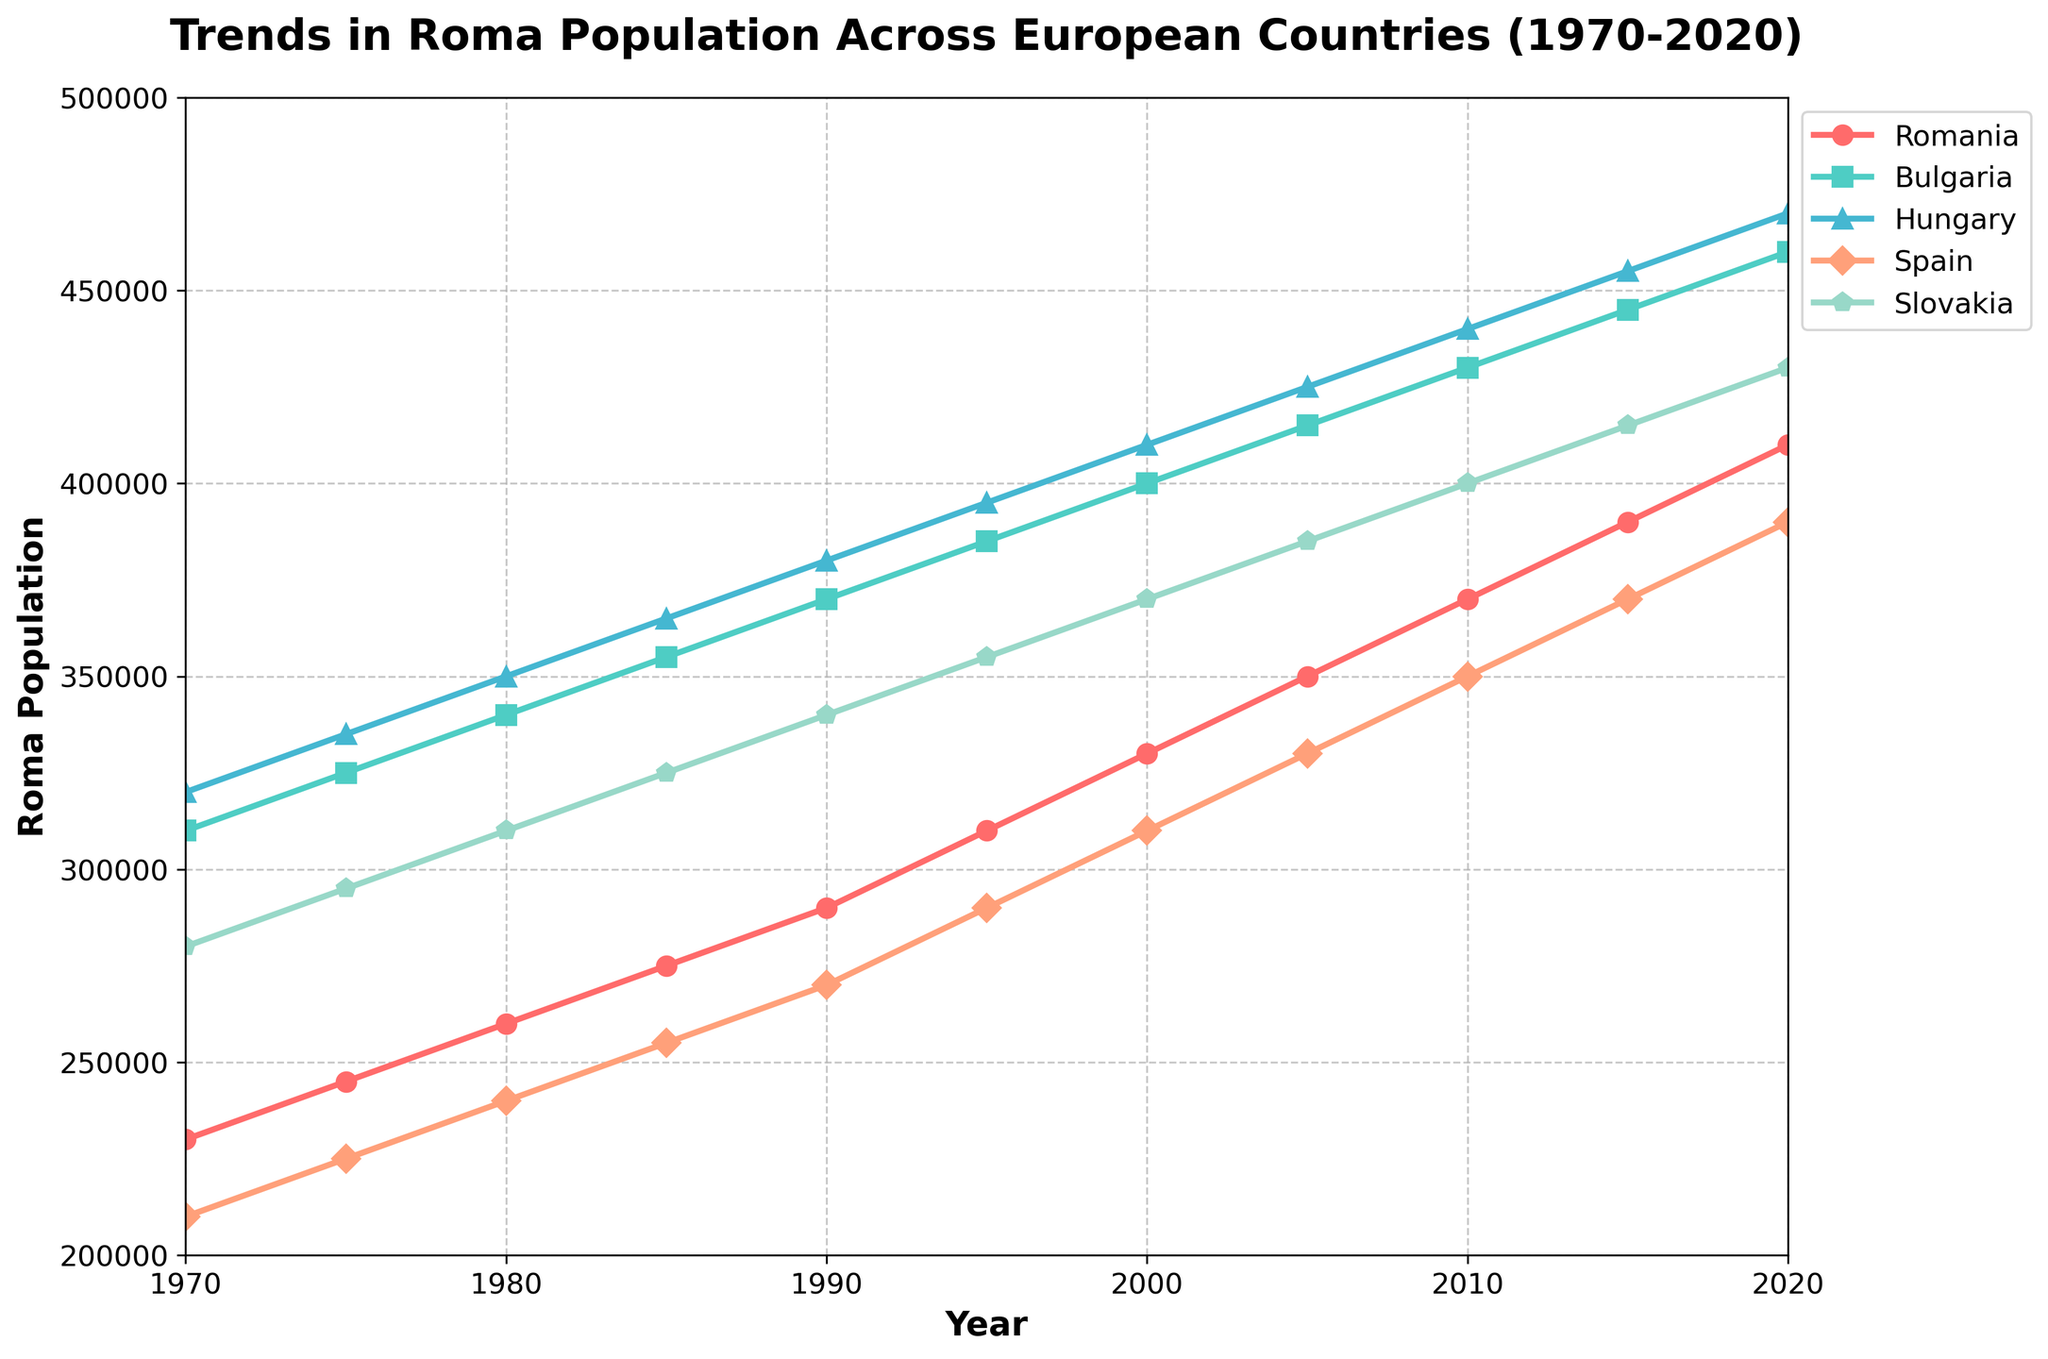What is the trend in the Roma population for Romania from 1970 to 2020? The line representing Romania's Roma population starts from 230,000 in 1970 and steadily increases to 410,000 in 2020, indicating a continuous upward trend.
Answer: Continuous upward trend Which country had the highest Roma population in 2020? By comparing the endpoints of all lines in 2020, Bulgaria's line reaches 460,000, which is higher than the lines of Romania, Hungary, Spain, and Slovakia.
Answer: Bulgaria What is the difference in Roma population between Hungary and Spain in 2010? In 2010, Hungary's Roma population is 440,000, and Spain's is 350,000. The difference is calculated by subtracting 350,000 from 440,000.
Answer: 90,000 Which country experienced the greatest increase in Roma population between 1970 and 2020? By examining the lengths of the lines' increase, Bulgaria increased from 310,000 to 460,000, an increase of 150,000; no other country shows a larger increase.
Answer: Bulgaria In which year did Romania's Roma population first exceed 300,000? The line for Romania crosses the 300,000 mark between 1990 (290,000) and 1995 (310,000), indicating the population first exceeded 300,000 in 1995.
Answer: 1995 Compare the Roma population of Slovakia and Spain in 1990. Which country had more, and by how much? In 1990, Slovakia's Roma population is 340,000, while Spain's is 270,000. Slovakia had 340,000 - 270,000 more.
Answer: Slovakia, 70,000 What is the average Roma population in Bulgaria from 1970 to 2020? Bulgaria's population values are: 310,000, 325,000, 340,000, 355,000, 370,000, 385,000, 400,000, 415,000, 430,000, 445,000, 460,000. Adding these values and dividing the sum by 11 gives the average.
Answer: 380,000 How does the overall trend in Roma population in Hungary compare with that in Slovakia over the 50-year period? Both countries show a steady increase from 320,000 to 470,000 for Hungary and 280,000 to 430,000 for Slovakia; hence, both trends are upward.
Answer: Both upward 